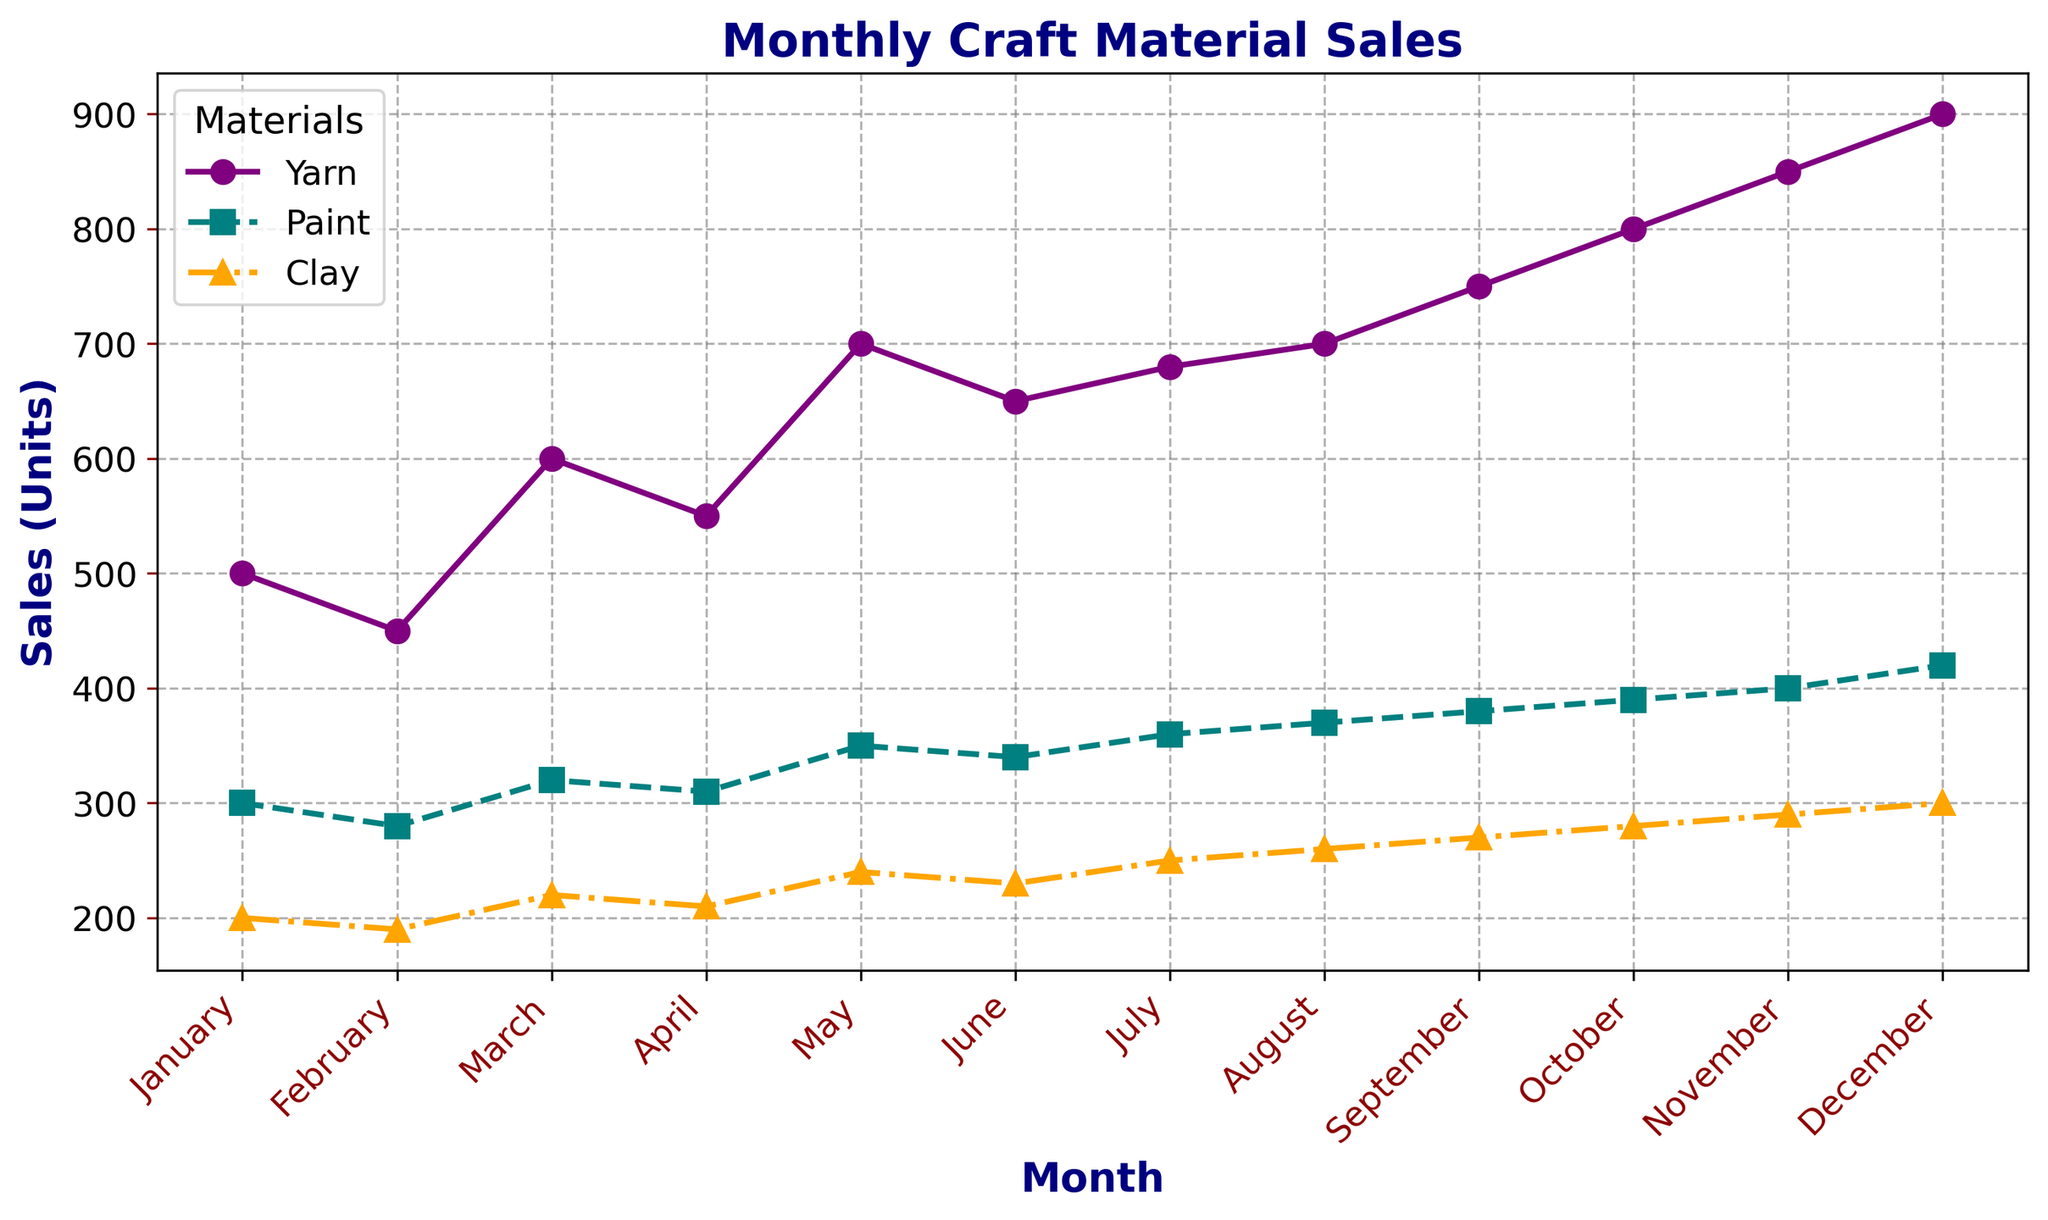Which material has the highest sales in December? From the chart, observe the endpoints of each line for December. The purple line (Yarn) is highest, followed by the teal line (Paint), and the orange line (Clay).
Answer: Yarn What is the difference in clay sales between November and December? Observe the y-values of the clay sales line (orange) for November and December. In November the value is 290, and in December it is 300. Subtract 290 from 300.
Answer: 10 units How do yarn sales in April compare with paint sales in June? Observe the y-values for yarn in April (550) and paint in June (340). Notice that in April, the yarn sales are higher than the paint sales in June.
Answer: Yarn sales are higher Calculate the average sales of paint over the summer months (June, July, August). Check the y-values for paint in June (340), July (360), and August (370). Sum them up (340 + 360 + 370 = 1070) and divide by 3.
Answer: 357 units Which month shows the highest increase in yarn sales compared to the previous month? Observe the wooden endpoints and note the changes in y-values between each point. The largest jump occurs from November (850) to December (900).
Answer: December Do sales of any material consistently increase every month? Follow each line from left (January) to right (December). Yarn continually increases each month without any dips.
Answer: Yarn What is the sum of the sales for all materials in May? Check the y-values for yarn, paint, and clay in May (700 + 350 + 240 = 1290).
Answer: 1290 units What is the trend for paint sales from May to October? Look at the paint sales line (teal) from May to October. It shows a steady rise every month (350, 340, 360, 370, 380, 390).
Answer: Increasing trend By how much do yarn sales exceed clay sales in January? Compare the y-values of yarn (500) and clay (200) in January. Subtract 200 from 500.
Answer: 300 units If you combine the sales of all materials in January, what would the total be? Add the y-values for yarn (500), paint (300), and clay (200) in January (500 + 300 + 200 = 1000).
Answer: 1000 units 